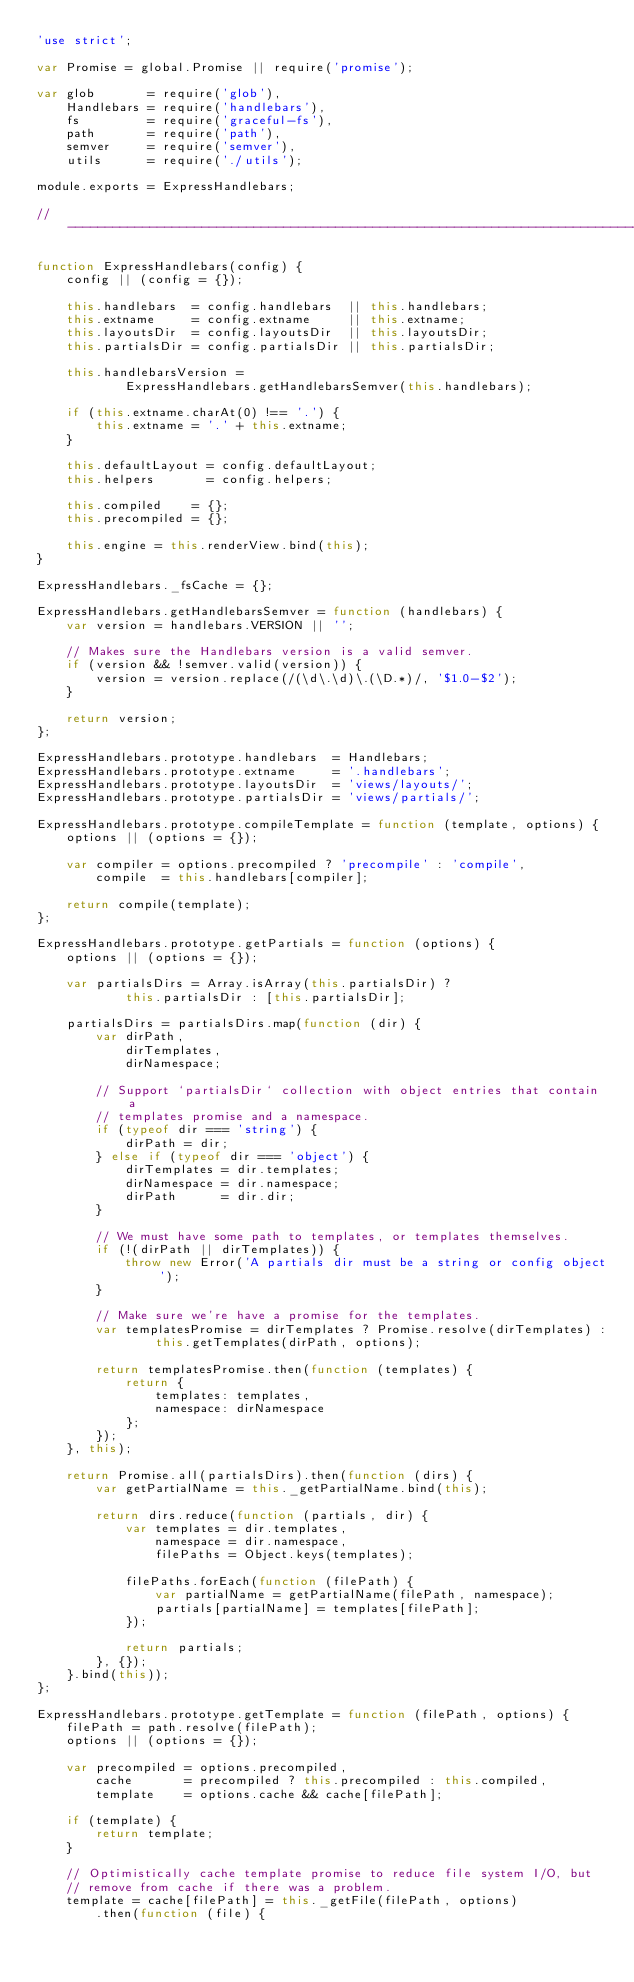<code> <loc_0><loc_0><loc_500><loc_500><_JavaScript_>'use strict';

var Promise = global.Promise || require('promise');

var glob       = require('glob'),
    Handlebars = require('handlebars'),
    fs         = require('graceful-fs'),
    path       = require('path'),
    semver     = require('semver'),
    utils      = require('./utils');

module.exports = ExpressHandlebars;

// -----------------------------------------------------------------------------

function ExpressHandlebars(config) {
    config || (config = {});

    this.handlebars  = config.handlebars  || this.handlebars;
    this.extname     = config.extname     || this.extname;
    this.layoutsDir  = config.layoutsDir  || this.layoutsDir;
    this.partialsDir = config.partialsDir || this.partialsDir;

    this.handlebarsVersion =
            ExpressHandlebars.getHandlebarsSemver(this.handlebars);

    if (this.extname.charAt(0) !== '.') {
        this.extname = '.' + this.extname;
    }

    this.defaultLayout = config.defaultLayout;
    this.helpers       = config.helpers;

    this.compiled    = {};
    this.precompiled = {};

    this.engine = this.renderView.bind(this);
}

ExpressHandlebars._fsCache = {};

ExpressHandlebars.getHandlebarsSemver = function (handlebars) {
    var version = handlebars.VERSION || '';

    // Makes sure the Handlebars version is a valid semver.
    if (version && !semver.valid(version)) {
        version = version.replace(/(\d\.\d)\.(\D.*)/, '$1.0-$2');
    }

    return version;
};

ExpressHandlebars.prototype.handlebars  = Handlebars;
ExpressHandlebars.prototype.extname     = '.handlebars';
ExpressHandlebars.prototype.layoutsDir  = 'views/layouts/';
ExpressHandlebars.prototype.partialsDir = 'views/partials/';

ExpressHandlebars.prototype.compileTemplate = function (template, options) {
    options || (options = {});

    var compiler = options.precompiled ? 'precompile' : 'compile',
        compile  = this.handlebars[compiler];

    return compile(template);
};

ExpressHandlebars.prototype.getPartials = function (options) {
    options || (options = {});

    var partialsDirs = Array.isArray(this.partialsDir) ?
            this.partialsDir : [this.partialsDir];

    partialsDirs = partialsDirs.map(function (dir) {
        var dirPath,
            dirTemplates,
            dirNamespace;

        // Support `partialsDir` collection with object entries that contain a
        // templates promise and a namespace.
        if (typeof dir === 'string') {
            dirPath = dir;
        } else if (typeof dir === 'object') {
            dirTemplates = dir.templates;
            dirNamespace = dir.namespace;
            dirPath      = dir.dir;
        }

        // We must have some path to templates, or templates themselves.
        if (!(dirPath || dirTemplates)) {
            throw new Error('A partials dir must be a string or config object');
        }

        // Make sure we're have a promise for the templates.
        var templatesPromise = dirTemplates ? Promise.resolve(dirTemplates) :
                this.getTemplates(dirPath, options);

        return templatesPromise.then(function (templates) {
            return {
                templates: templates,
                namespace: dirNamespace
            };
        });
    }, this);

    return Promise.all(partialsDirs).then(function (dirs) {
        var getPartialName = this._getPartialName.bind(this);

        return dirs.reduce(function (partials, dir) {
            var templates = dir.templates,
                namespace = dir.namespace,
                filePaths = Object.keys(templates);

            filePaths.forEach(function (filePath) {
                var partialName = getPartialName(filePath, namespace);
                partials[partialName] = templates[filePath];
            });

            return partials;
        }, {});
    }.bind(this));
};

ExpressHandlebars.prototype.getTemplate = function (filePath, options) {
    filePath = path.resolve(filePath);
    options || (options = {});

    var precompiled = options.precompiled,
        cache       = precompiled ? this.precompiled : this.compiled,
        template    = options.cache && cache[filePath];

    if (template) {
        return template;
    }

    // Optimistically cache template promise to reduce file system I/O, but
    // remove from cache if there was a problem.
    template = cache[filePath] = this._getFile(filePath, options)
        .then(function (file) {</code> 